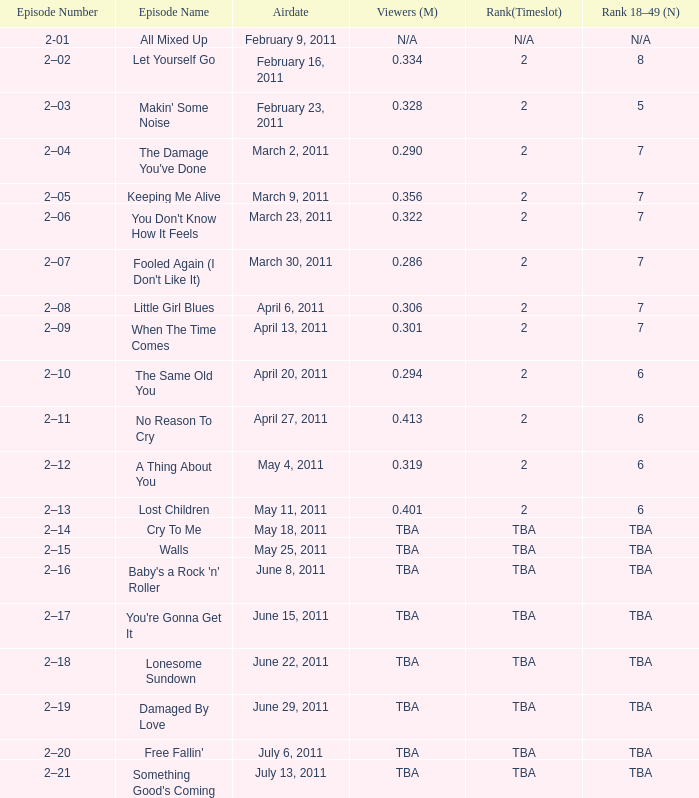What is the total rank on airdate march 30, 2011? 1.0. 